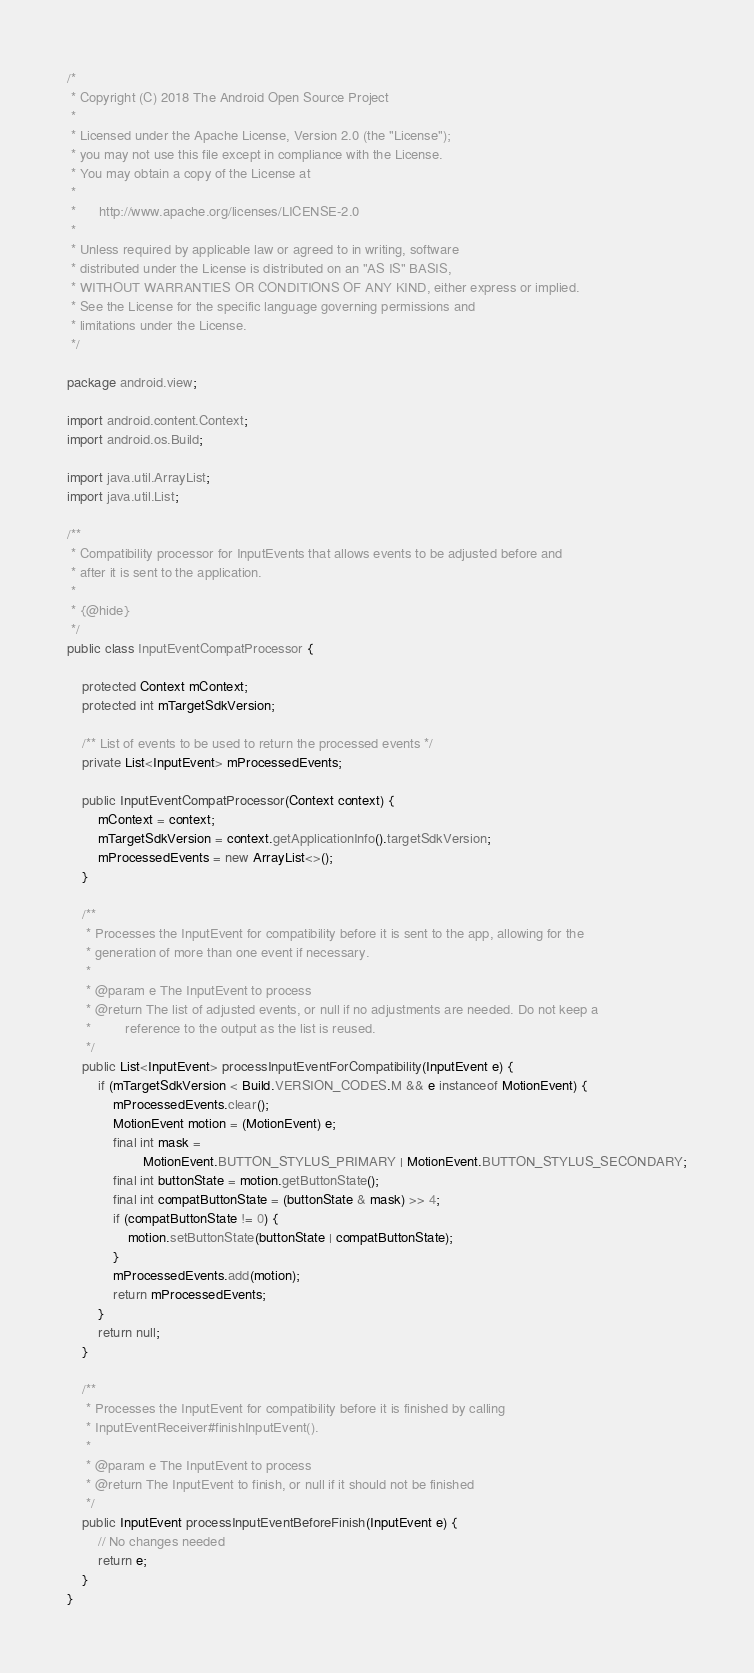<code> <loc_0><loc_0><loc_500><loc_500><_Java_>/*
 * Copyright (C) 2018 The Android Open Source Project
 *
 * Licensed under the Apache License, Version 2.0 (the "License");
 * you may not use this file except in compliance with the License.
 * You may obtain a copy of the License at
 *
 *      http://www.apache.org/licenses/LICENSE-2.0
 *
 * Unless required by applicable law or agreed to in writing, software
 * distributed under the License is distributed on an "AS IS" BASIS,
 * WITHOUT WARRANTIES OR CONDITIONS OF ANY KIND, either express or implied.
 * See the License for the specific language governing permissions and
 * limitations under the License.
 */

package android.view;

import android.content.Context;
import android.os.Build;

import java.util.ArrayList;
import java.util.List;

/**
 * Compatibility processor for InputEvents that allows events to be adjusted before and
 * after it is sent to the application.
 *
 * {@hide}
 */
public class InputEventCompatProcessor {

    protected Context mContext;
    protected int mTargetSdkVersion;

    /** List of events to be used to return the processed events */
    private List<InputEvent> mProcessedEvents;

    public InputEventCompatProcessor(Context context) {
        mContext = context;
        mTargetSdkVersion = context.getApplicationInfo().targetSdkVersion;
        mProcessedEvents = new ArrayList<>();
    }

    /**
     * Processes the InputEvent for compatibility before it is sent to the app, allowing for the
     * generation of more than one event if necessary.
     *
     * @param e The InputEvent to process
     * @return The list of adjusted events, or null if no adjustments are needed. Do not keep a
     *         reference to the output as the list is reused.
     */
    public List<InputEvent> processInputEventForCompatibility(InputEvent e) {
        if (mTargetSdkVersion < Build.VERSION_CODES.M && e instanceof MotionEvent) {
            mProcessedEvents.clear();
            MotionEvent motion = (MotionEvent) e;
            final int mask =
                    MotionEvent.BUTTON_STYLUS_PRIMARY | MotionEvent.BUTTON_STYLUS_SECONDARY;
            final int buttonState = motion.getButtonState();
            final int compatButtonState = (buttonState & mask) >> 4;
            if (compatButtonState != 0) {
                motion.setButtonState(buttonState | compatButtonState);
            }
            mProcessedEvents.add(motion);
            return mProcessedEvents;
        }
        return null;
    }

    /**
     * Processes the InputEvent for compatibility before it is finished by calling
     * InputEventReceiver#finishInputEvent().
     *
     * @param e The InputEvent to process
     * @return The InputEvent to finish, or null if it should not be finished
     */
    public InputEvent processInputEventBeforeFinish(InputEvent e) {
        // No changes needed
        return e;
    }
}
</code> 